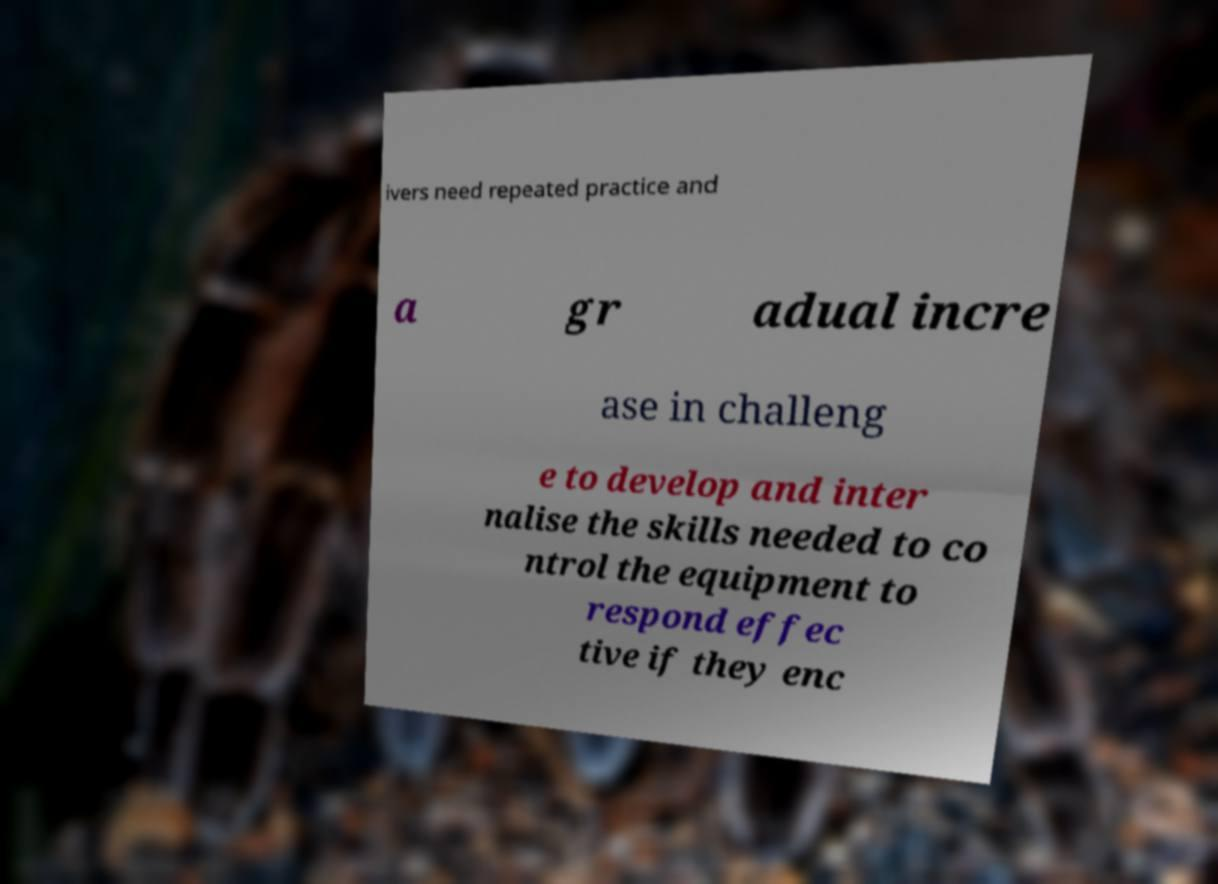There's text embedded in this image that I need extracted. Can you transcribe it verbatim? ivers need repeated practice and a gr adual incre ase in challeng e to develop and inter nalise the skills needed to co ntrol the equipment to respond effec tive if they enc 